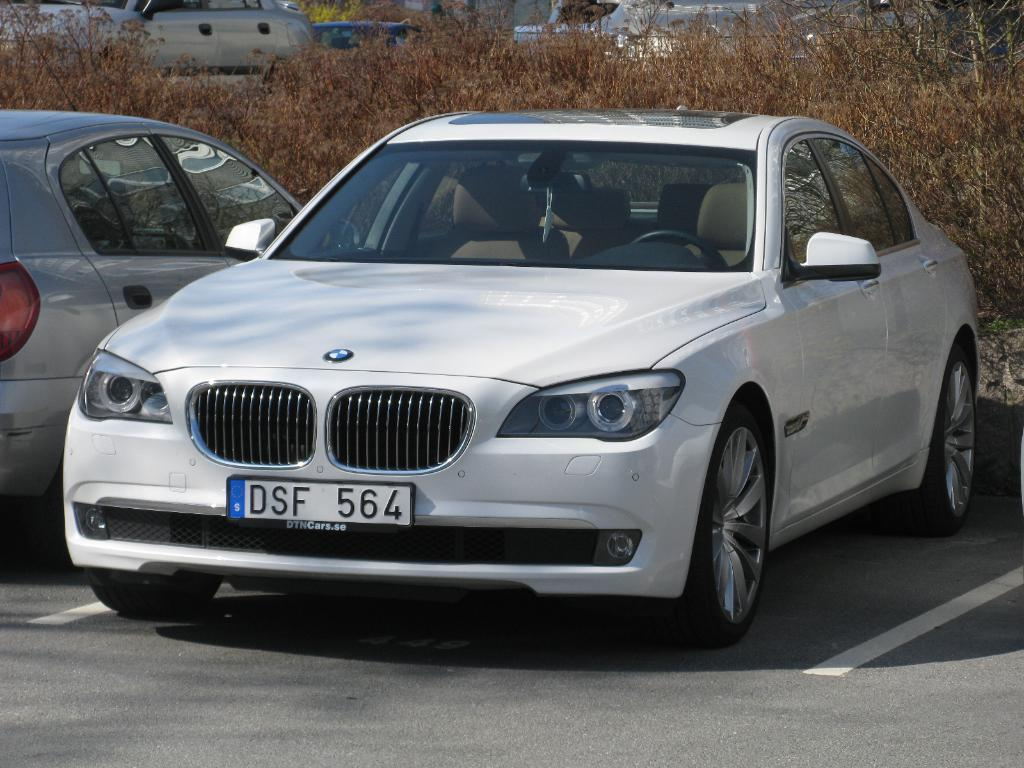What type of car is in the image? There is a BMW car in the image. What color is the BMW car? The BMW car is white. Where is the BMW car located in the image? The BMW car is parked beside the road. What is the position of the other car in relation to the BMW? There is another car beside the BMW. What can be seen behind the cars in the image? There are dry plants behind the cars. What direction is the zephyr blowing in the image? There is no mention of a zephyr or any wind in the image, so it cannot be determined which direction it might be blowing. 